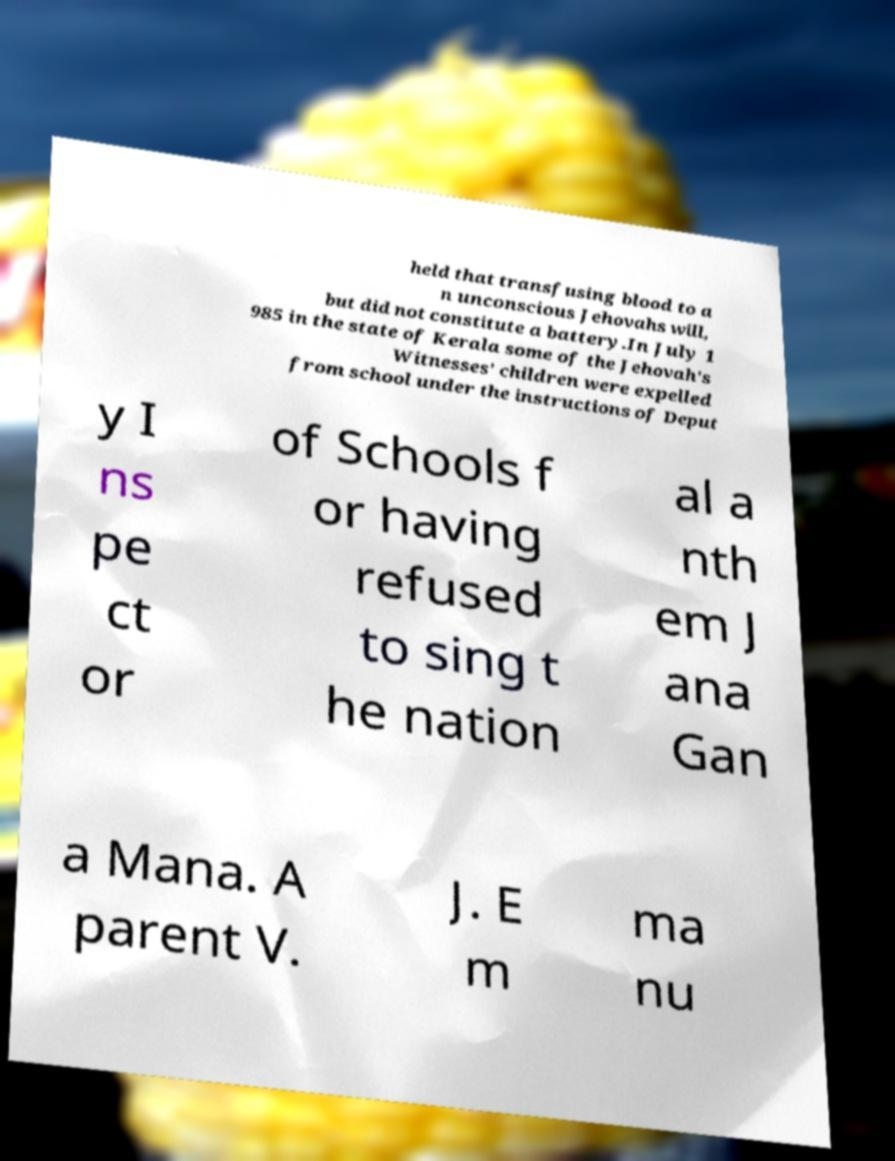For documentation purposes, I need the text within this image transcribed. Could you provide that? held that transfusing blood to a n unconscious Jehovahs will, but did not constitute a battery.In July 1 985 in the state of Kerala some of the Jehovah's Witnesses' children were expelled from school under the instructions of Deput y I ns pe ct or of Schools f or having refused to sing t he nation al a nth em J ana Gan a Mana. A parent V. J. E m ma nu 